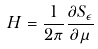<formula> <loc_0><loc_0><loc_500><loc_500>H = \frac { 1 } { 2 \pi } \frac { \partial S _ { \epsilon } } { \partial \mu } \</formula> 